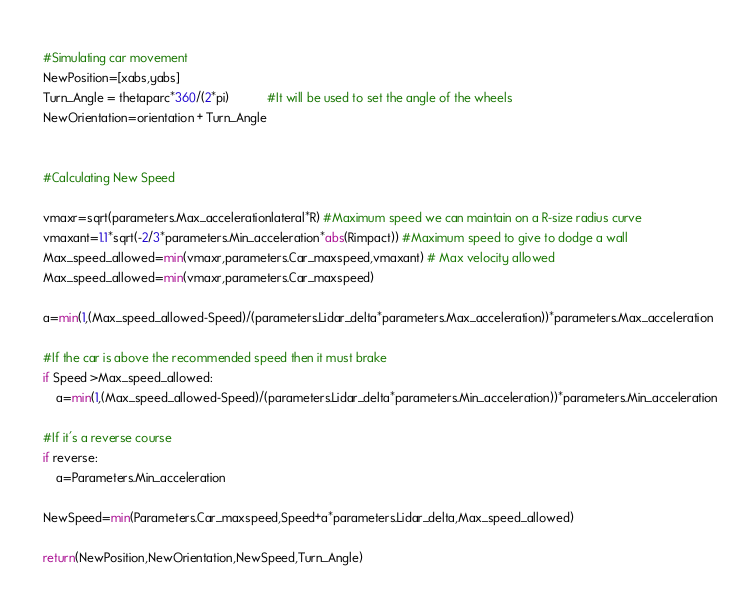<code> <loc_0><loc_0><loc_500><loc_500><_Python_>    
    #Simulating car movement 
    NewPosition=[xabs,yabs]
    Turn_Angle = thetaparc*360/(2*pi)           #It will be used to set the angle of the wheels
    NewOrientation=orientation + Turn_Angle
       
    
    #Calculating New Speed
    
    vmaxr=sqrt(parameters.Max_accelerationlateral*R) #Maximum speed we can maintain on a R-size radius curve
    vmaxant=1.1*sqrt(-2/3*parameters.Min_acceleration*abs(Rimpact)) #Maximum speed to give to dodge a wall        
    Max_speed_allowed=min(vmaxr,parameters.Car_maxspeed,vmaxant) # Max velocity allowed
    Max_speed_allowed=min(vmaxr,parameters.Car_maxspeed)
    
    a=min(1,(Max_speed_allowed-Speed)/(parameters.Lidar_delta*parameters.Max_acceleration))*parameters.Max_acceleration
    
    #If the car is above the recommended speed then it must brake
    if Speed >Max_speed_allowed:
        a=min(1,(Max_speed_allowed-Speed)/(parameters.Lidar_delta*parameters.Min_acceleration))*parameters.Min_acceleration
    
    #If it's a reverse course
    if reverse:
        a=Parameters.Min_acceleration
    
    NewSpeed=min(Parameters.Car_maxspeed,Speed+a*parameters.Lidar_delta,Max_speed_allowed)
   
    return(NewPosition,NewOrientation,NewSpeed,Turn_Angle)






</code> 